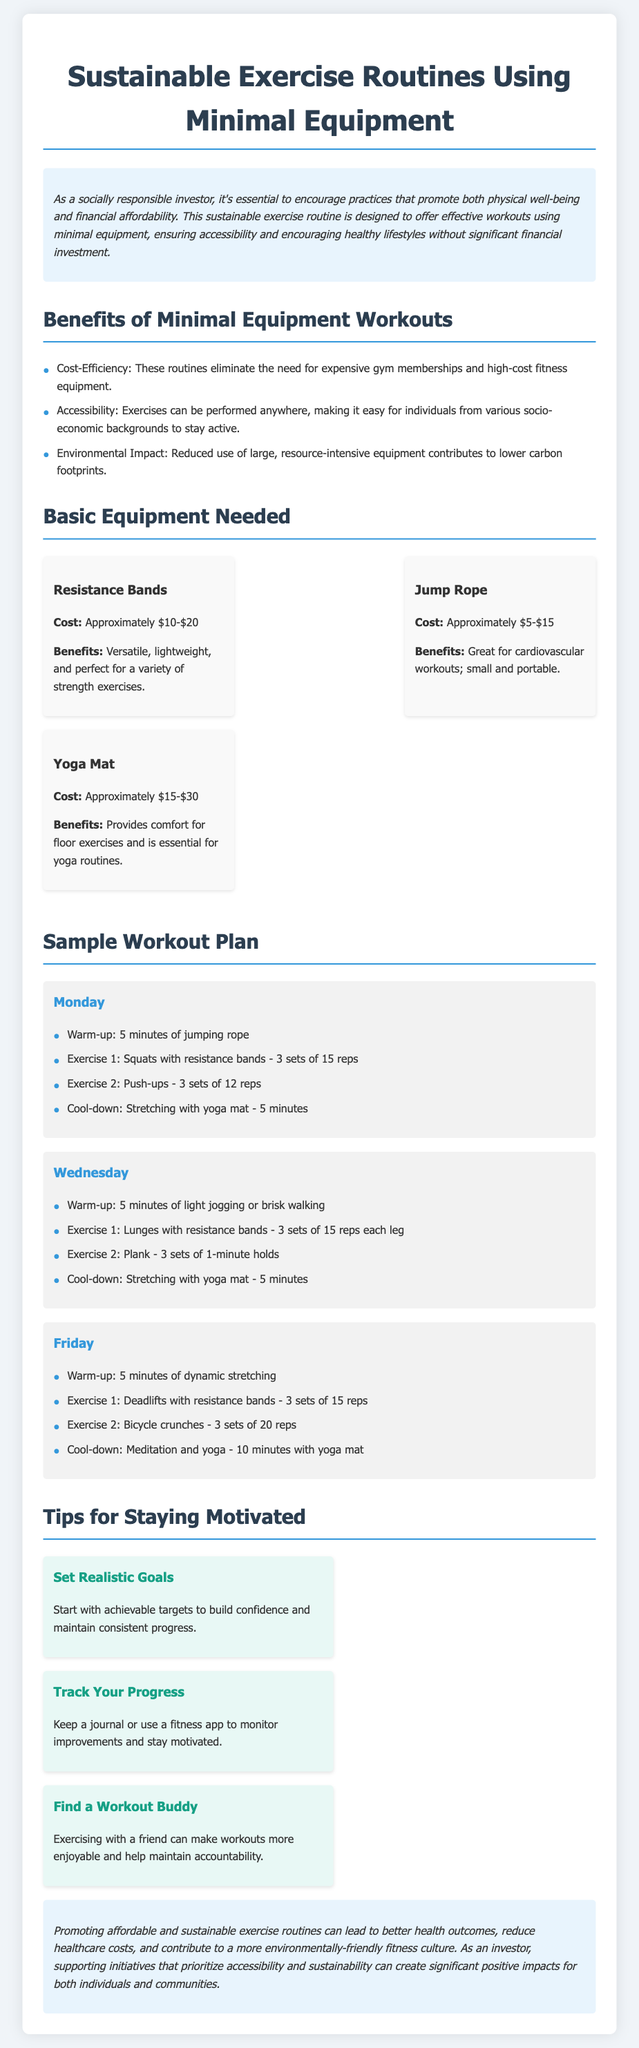what are the benefits of minimal equipment workouts? The document lists multiple benefits including cost-efficiency, accessibility, and environmental impact.
Answer: cost-efficiency, accessibility, environmental impact how much does a jump rope cost? The document provides a cost range for the jump rope as specified in the section about basic equipment.
Answer: approximately $5-$15 what exercise is suggested for Monday's workout plan? The document outlines specific exercises for each day with details provided for Monday's workout plan.
Answer: squats with resistance bands how many sets of bicycle crunches are recommended for Friday? The document specifies the number of sets for each exercise listed in Friday's workout section.
Answer: 3 sets what is suggested as a tip for staying motivated? The document highlights various tips in a dedicated section with specific suggestions for motivation.
Answer: set realistic goals how long should you meditate and do yoga on Friday? The document provides details about the duration for each activity during the Friday workout day.
Answer: 10 minutes which day is dedicated to lunges with resistance bands? The workouts are labeled by day, and lunges are included in the specific workout routines.
Answer: Wednesday what type of mat is highlighted in the basic equipment section? The document outlines basic equipment necessary for the workouts and mentions a specific type of mat.
Answer: yoga mat 